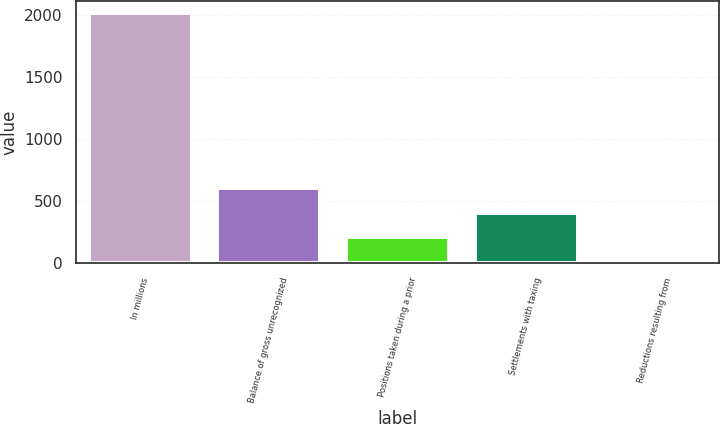<chart> <loc_0><loc_0><loc_500><loc_500><bar_chart><fcel>In millions<fcel>Balance of gross unrecognized<fcel>Positions taken during a prior<fcel>Settlements with taxing<fcel>Reductions resulting from<nl><fcel>2013<fcel>608.8<fcel>207.6<fcel>408.2<fcel>7<nl></chart> 